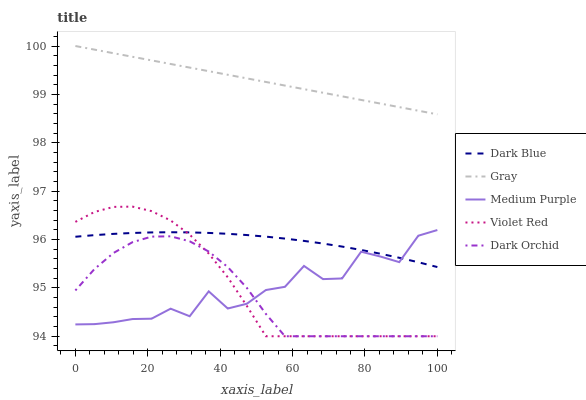Does Dark Orchid have the minimum area under the curve?
Answer yes or no. Yes. Does Gray have the maximum area under the curve?
Answer yes or no. Yes. Does Dark Blue have the minimum area under the curve?
Answer yes or no. No. Does Dark Blue have the maximum area under the curve?
Answer yes or no. No. Is Gray the smoothest?
Answer yes or no. Yes. Is Medium Purple the roughest?
Answer yes or no. Yes. Is Dark Blue the smoothest?
Answer yes or no. No. Is Dark Blue the roughest?
Answer yes or no. No. Does Violet Red have the lowest value?
Answer yes or no. Yes. Does Dark Blue have the lowest value?
Answer yes or no. No. Does Gray have the highest value?
Answer yes or no. Yes. Does Dark Blue have the highest value?
Answer yes or no. No. Is Dark Blue less than Gray?
Answer yes or no. Yes. Is Dark Blue greater than Dark Orchid?
Answer yes or no. Yes. Does Violet Red intersect Dark Blue?
Answer yes or no. Yes. Is Violet Red less than Dark Blue?
Answer yes or no. No. Is Violet Red greater than Dark Blue?
Answer yes or no. No. Does Dark Blue intersect Gray?
Answer yes or no. No. 